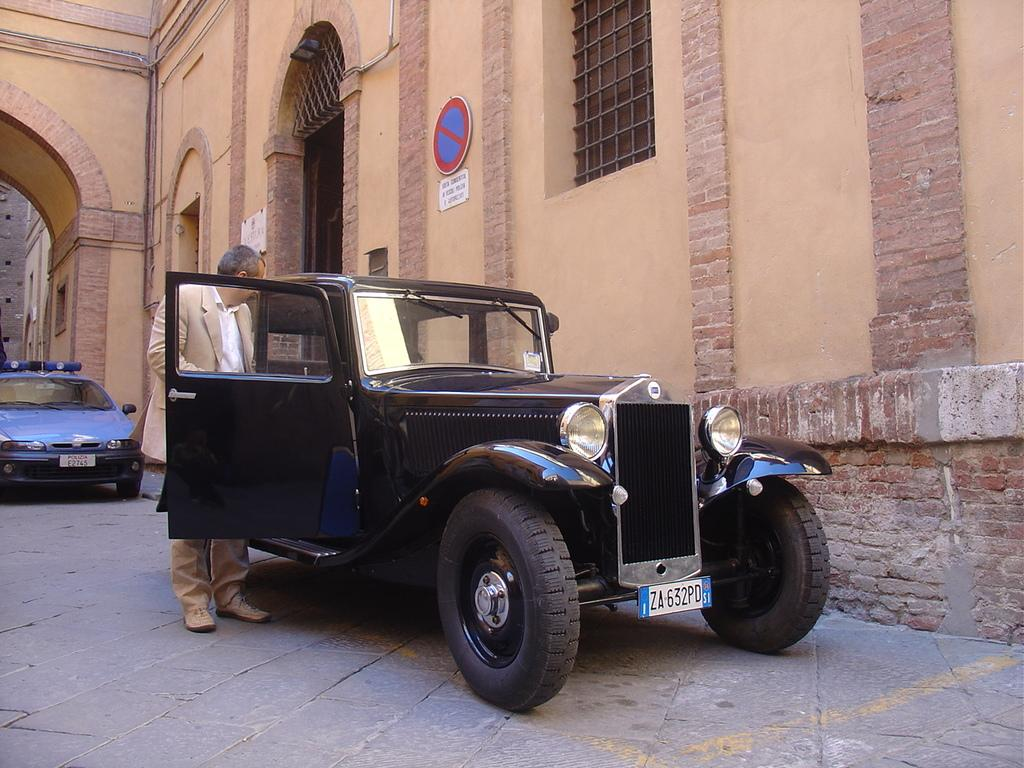What is the main subject of the image? The main subject of the image is a person standing near a car. Can you describe the setting of the image? There is a building in the background of the image. What color is the person's hair in the image? The provided facts do not mention the person's hair color, so we cannot determine the color of their hair from the image. 